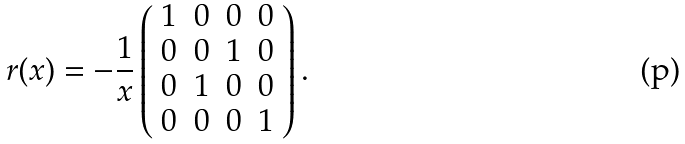Convert formula to latex. <formula><loc_0><loc_0><loc_500><loc_500>r ( x ) = - \frac { 1 } { x } \left ( \begin{array} { c c c c } 1 & 0 & 0 & 0 \\ 0 & 0 & 1 & 0 \\ 0 & 1 & 0 & 0 \\ 0 & 0 & 0 & 1 \\ \end{array} \right ) .</formula> 